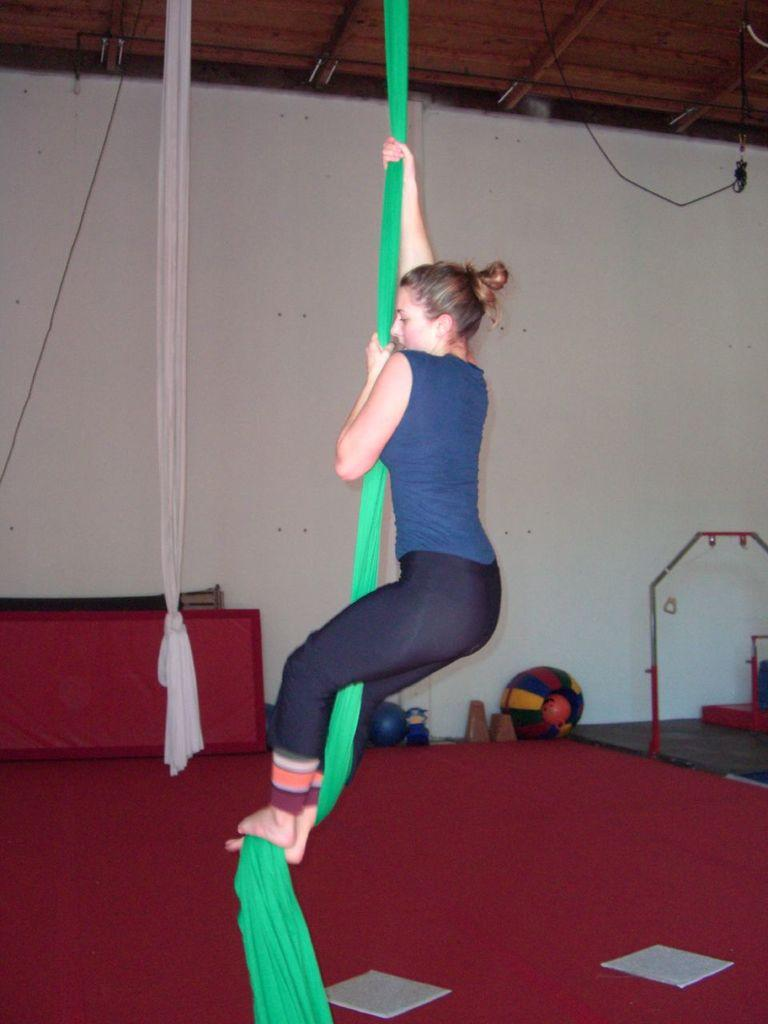What is the person in the image doing? The person in the image is doing gymnastics. What equipment is the person using for gymnastics? The person is using an aerial silk. Can you describe the background of the image? There is another aerial silk, balls, a wall, and other items visible in the background. What type of smile can be seen on the person's face while doing gymnastics? There is no indication of the person's facial expression in the image, so it cannot be determined if they are smiling or not. 